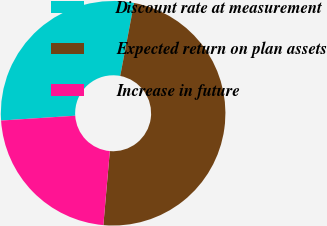<chart> <loc_0><loc_0><loc_500><loc_500><pie_chart><fcel>Discount rate at measurement<fcel>Expected return on plan assets<fcel>Increase in future<nl><fcel>29.03%<fcel>48.39%<fcel>22.58%<nl></chart> 